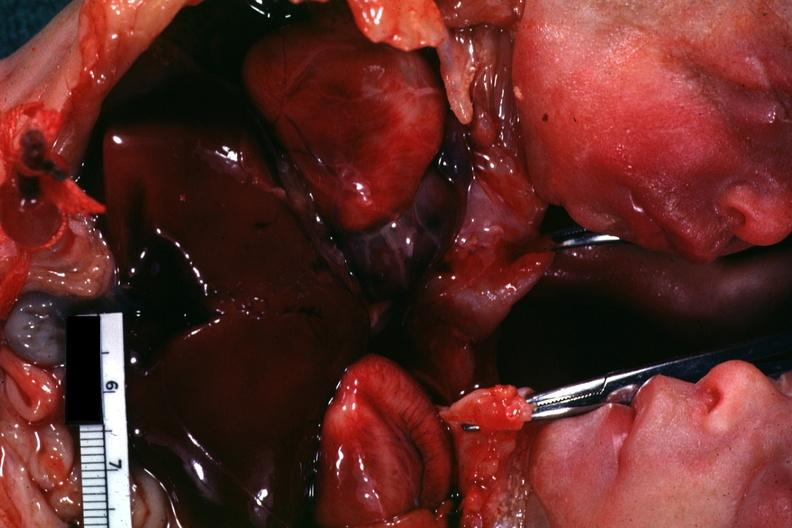what joined chest and abdomen slide shows opened chest with two hearts?
Answer the question using a single word or phrase. This 